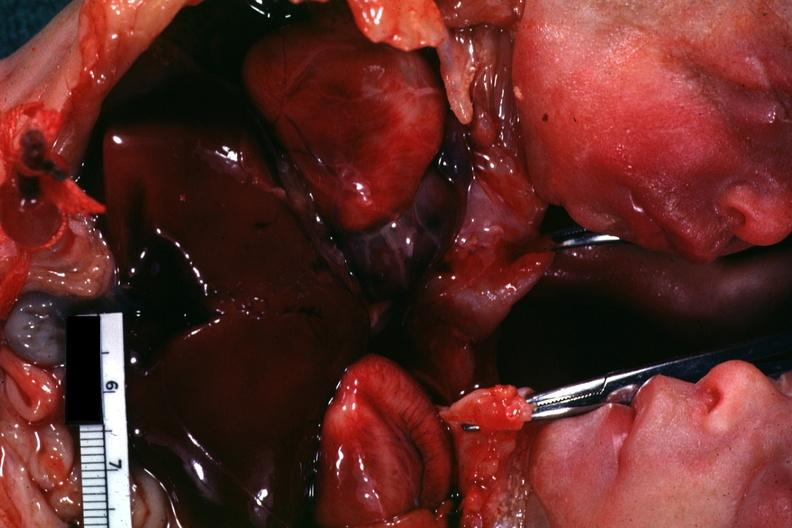what joined chest and abdomen slide shows opened chest with two hearts?
Answer the question using a single word or phrase. This 